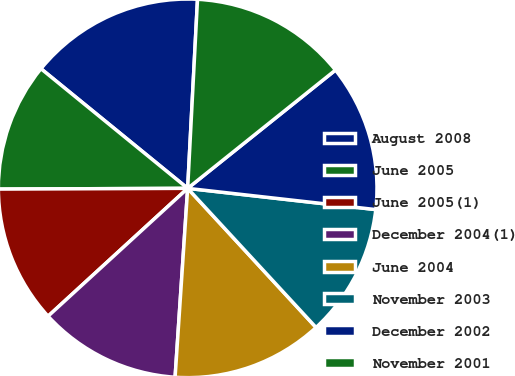<chart> <loc_0><loc_0><loc_500><loc_500><pie_chart><fcel>August 2008<fcel>June 2005<fcel>June 2005(1)<fcel>December 2004(1)<fcel>June 2004<fcel>November 2003<fcel>December 2002<fcel>November 2001<nl><fcel>14.94%<fcel>10.95%<fcel>11.74%<fcel>12.14%<fcel>12.92%<fcel>11.35%<fcel>12.53%<fcel>13.43%<nl></chart> 